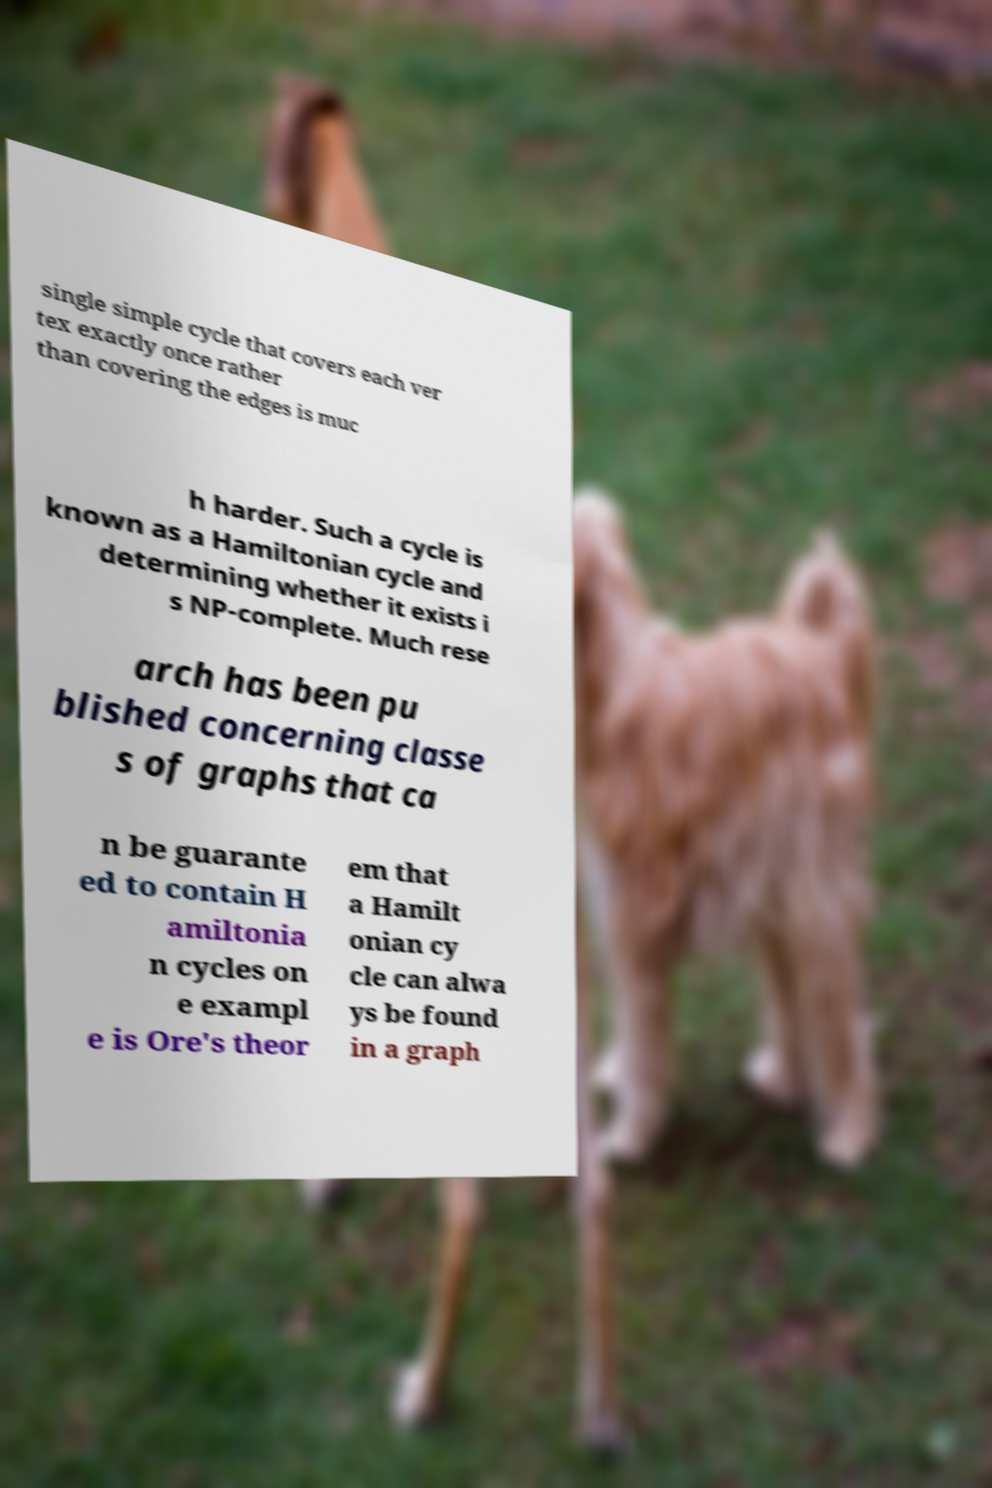Could you assist in decoding the text presented in this image and type it out clearly? single simple cycle that covers each ver tex exactly once rather than covering the edges is muc h harder. Such a cycle is known as a Hamiltonian cycle and determining whether it exists i s NP-complete. Much rese arch has been pu blished concerning classe s of graphs that ca n be guarante ed to contain H amiltonia n cycles on e exampl e is Ore's theor em that a Hamilt onian cy cle can alwa ys be found in a graph 